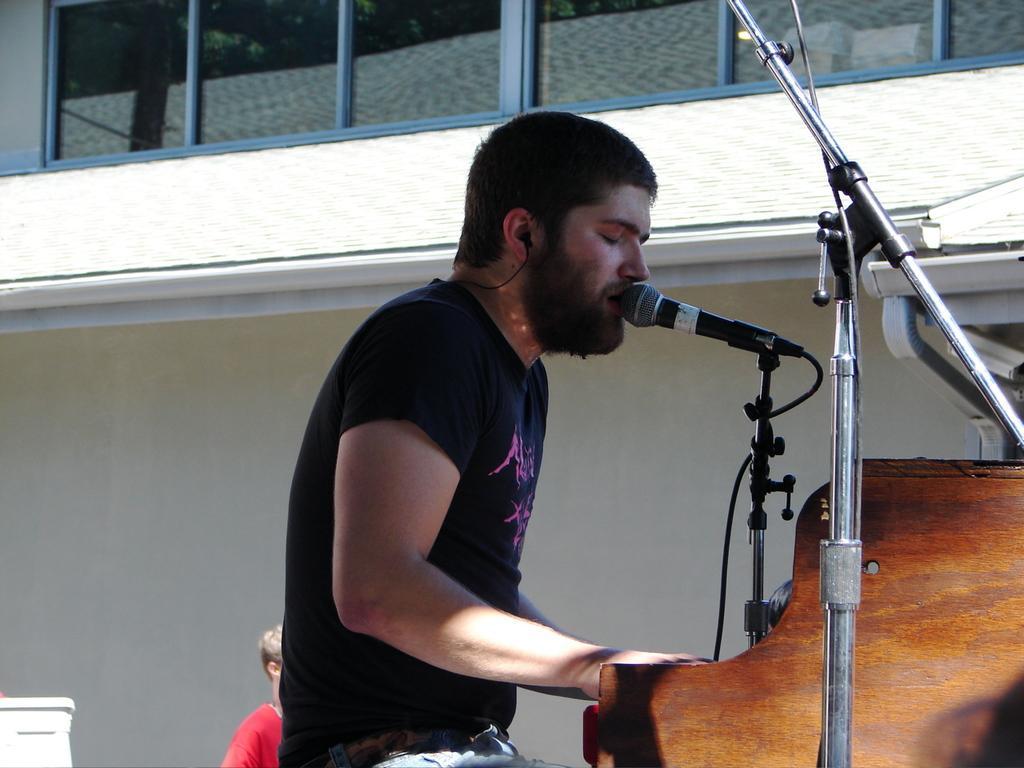How would you summarize this image in a sentence or two? In this image, we can see a person is singing in-front of microphone with wire and stand. Here we can see a wooden board, rods. Background there is a building with wall, glass windows, pipes, Here we can see another person. 